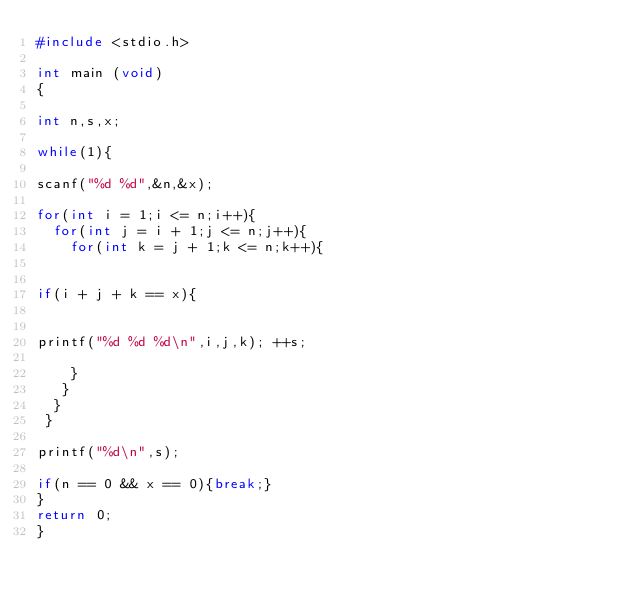<code> <loc_0><loc_0><loc_500><loc_500><_C_>#include <stdio.h>

int main (void) 
{

int n,s,x;

while(1){

scanf("%d %d",&n,&x);

for(int i = 1;i <= n;i++){
  for(int j = i + 1;j <= n;j++){
    for(int k = j + 1;k <= n;k++){


if(i + j + k == x){


printf("%d %d %d\n",i,j,k); ++s;

    }
   }
  }
 }

printf("%d\n",s);

if(n == 0 && x == 0){break;}
} 
return 0;
}</code> 